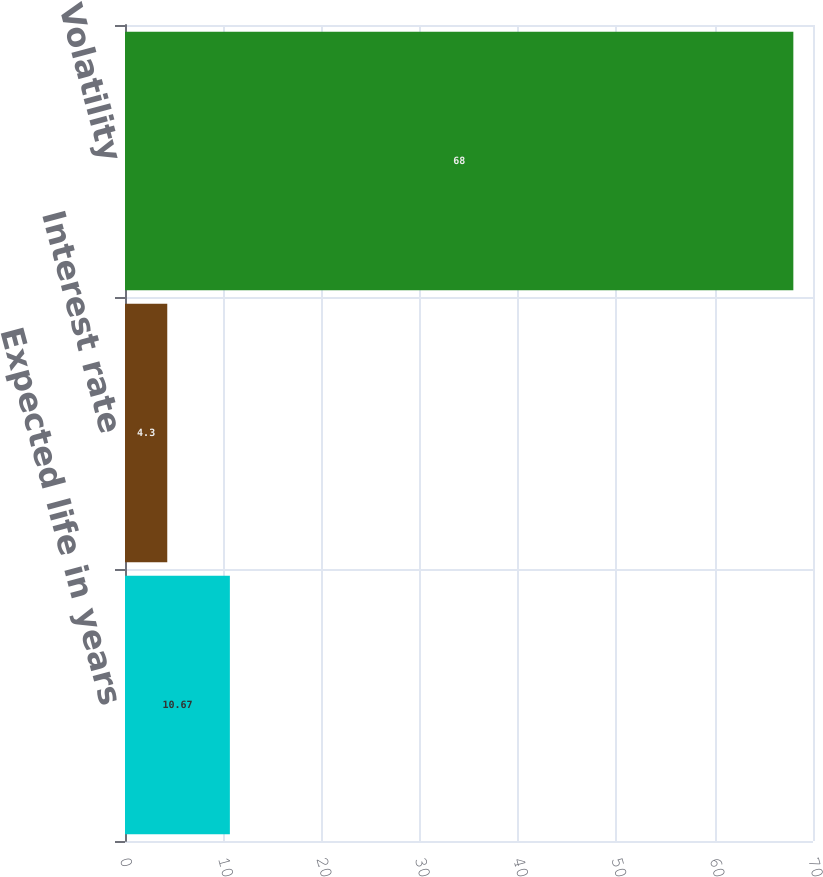Convert chart. <chart><loc_0><loc_0><loc_500><loc_500><bar_chart><fcel>Expected life in years<fcel>Interest rate<fcel>Volatility<nl><fcel>10.67<fcel>4.3<fcel>68<nl></chart> 